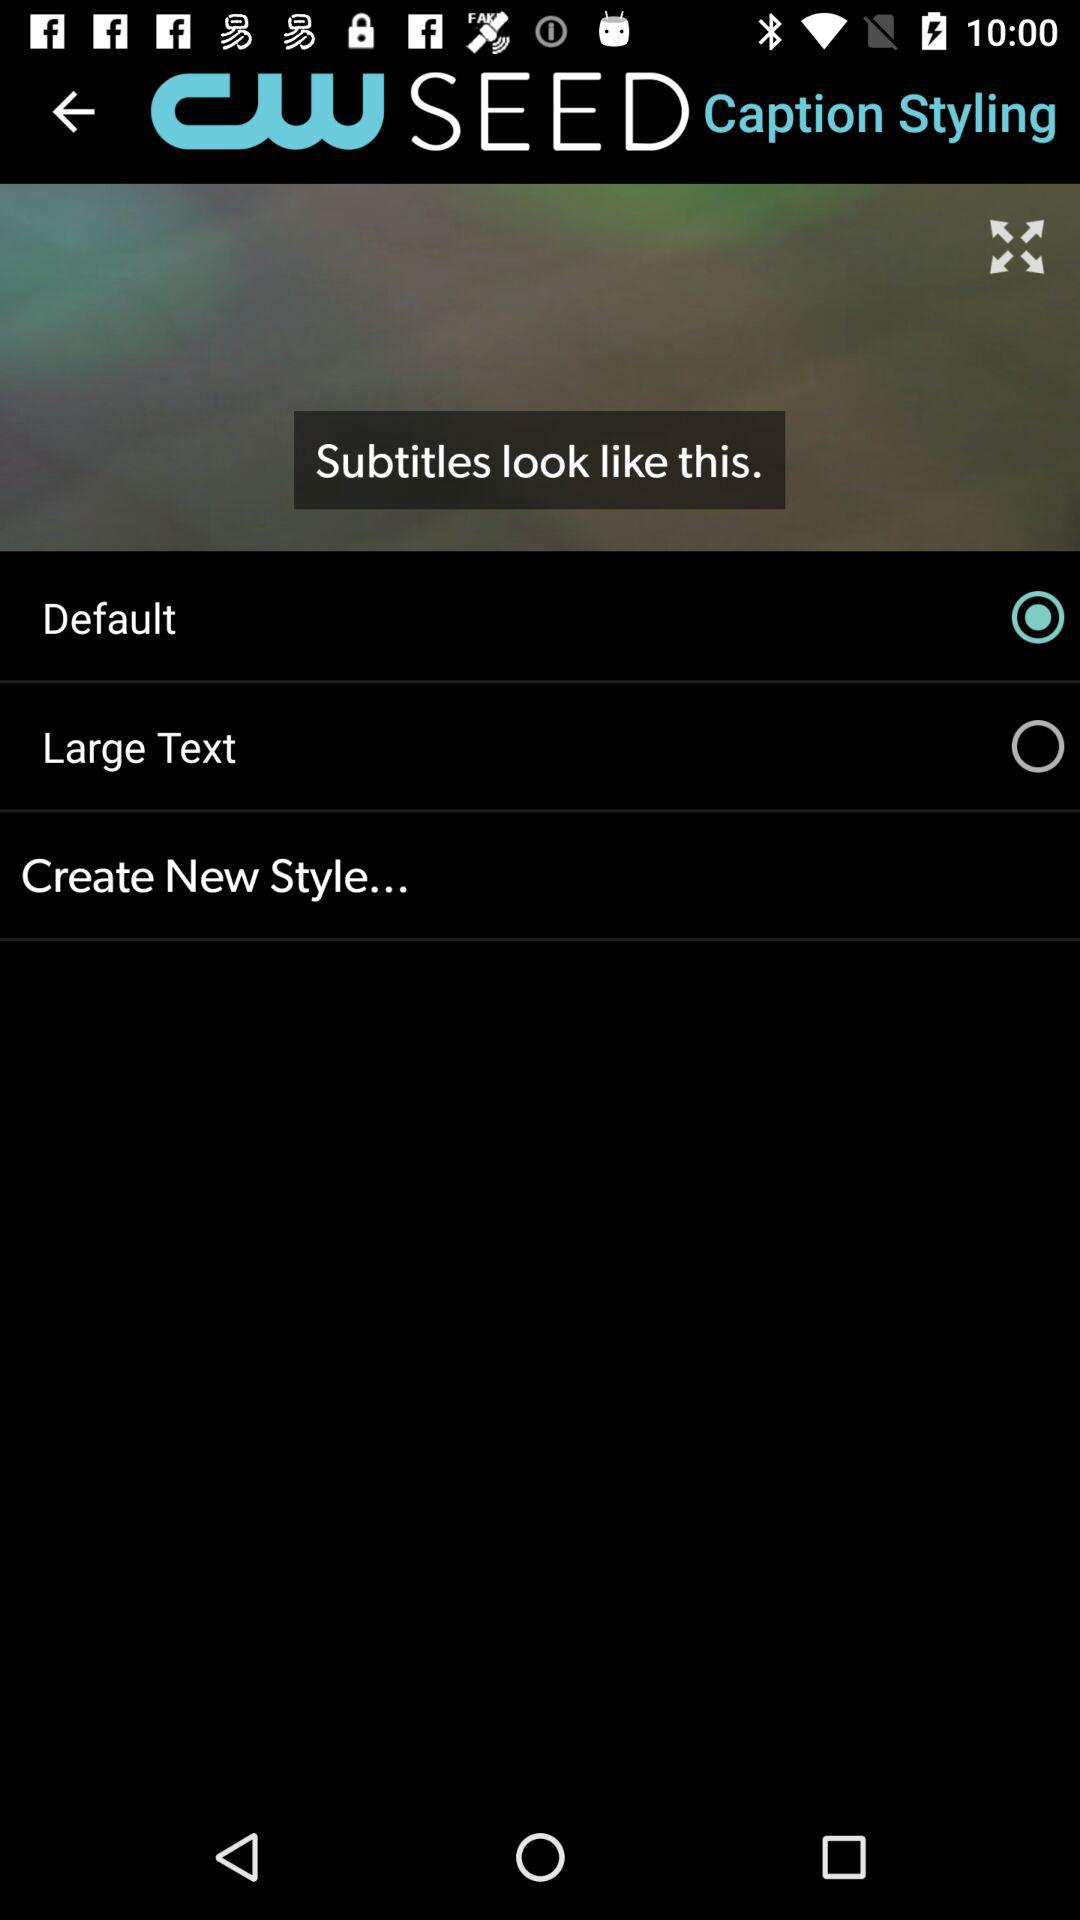What is the status of the "Default"? The status is "on". 